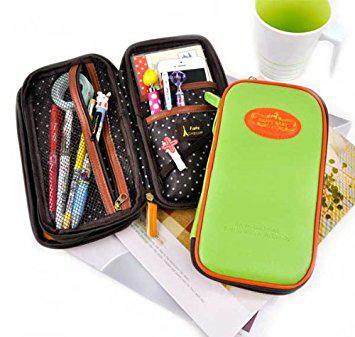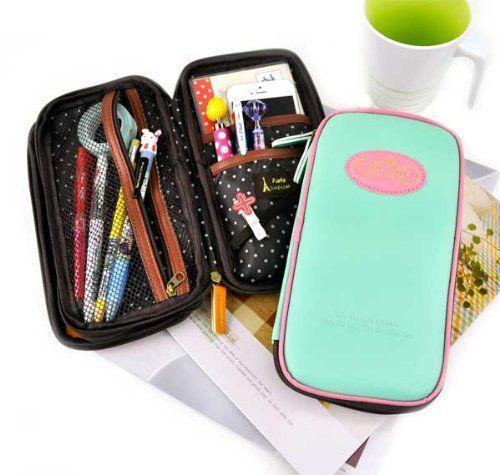The first image is the image on the left, the second image is the image on the right. Examine the images to the left and right. Is the description "Right and left images show the same number of pencil cases displayed in the same directional position." accurate? Answer yes or no. Yes. The first image is the image on the left, the second image is the image on the right. Assess this claim about the two images: "Four different variations of a pencil case, all of them closed, are depicted in one image.". Correct or not? Answer yes or no. No. The first image is the image on the left, the second image is the image on the right. Examine the images to the left and right. Is the description "In one image, a rectangular shaped case is shown in four different colors." accurate? Answer yes or no. No. The first image is the image on the left, the second image is the image on the right. Examine the images to the left and right. Is the description "The left image shows exactly four pencil cases on a white background." accurate? Answer yes or no. No. 